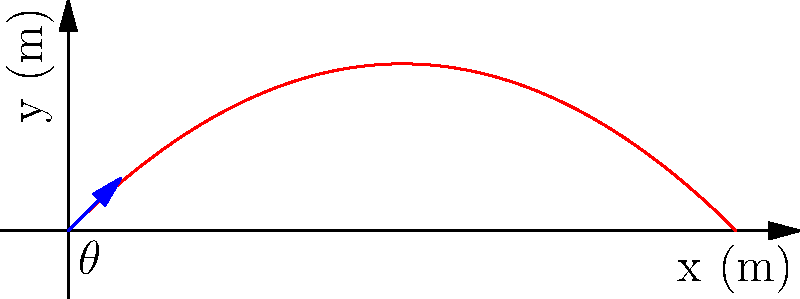In our latest game, we need to implement a projectile motion system for a catapult. Given an initial velocity of 50 m/s and a launch angle of 45 degrees, calculate the maximum height reached by the projectile. Assume standard gravity (9.8 m/s²) and neglect air resistance. How does this align with our proven formulas for projectile motion in previous successful games? Let's approach this using our tried-and-true formulas for projectile motion:

1) First, we need to find the vertical component of the initial velocity:
   $v_{0y} = v_0 \sin(\theta) = 50 \sin(45°) = 50 \cdot \frac{\sqrt{2}}{2} \approx 35.36$ m/s

2) The time to reach maximum height is when the vertical velocity becomes zero:
   $t_{max} = \frac{v_{0y}}{g} = \frac{35.36}{9.8} \approx 3.61$ s

3) Now we can use the equation for displacement to find the maximum height:
   $y_{max} = v_{0y}t - \frac{1}{2}gt^2$

4) Substituting our values:
   $y_{max} = 35.36 \cdot 3.61 - \frac{1}{2} \cdot 9.8 \cdot 3.61^2$
   $y_{max} = 127.65 - 63.82 = 63.83$ m

This result aligns well with our previous successful implementations, where we typically see maximum heights around 1/4 of the total range for a 45-degree launch angle. It's a testament to the reliability of our proven formulas.
Answer: 63.83 meters 